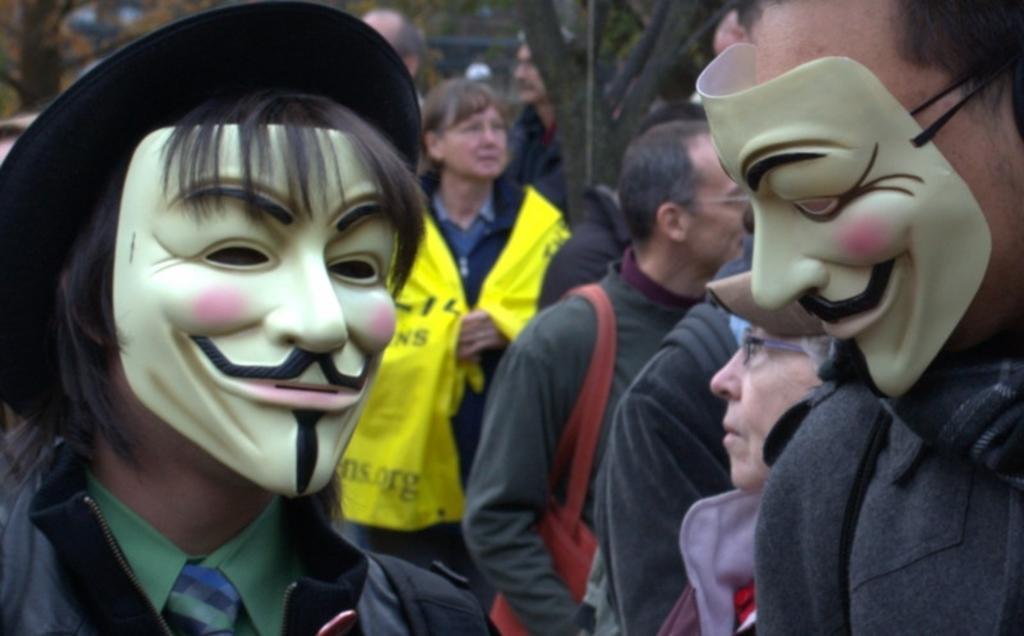Can you describe this image briefly? In this picture we can see 2 people wearing a mask. In the background, we see many people standing on the street. 